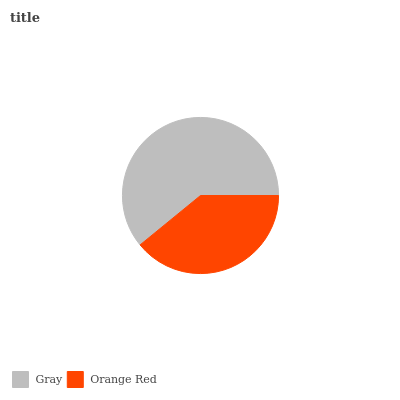Is Orange Red the minimum?
Answer yes or no. Yes. Is Gray the maximum?
Answer yes or no. Yes. Is Orange Red the maximum?
Answer yes or no. No. Is Gray greater than Orange Red?
Answer yes or no. Yes. Is Orange Red less than Gray?
Answer yes or no. Yes. Is Orange Red greater than Gray?
Answer yes or no. No. Is Gray less than Orange Red?
Answer yes or no. No. Is Gray the high median?
Answer yes or no. Yes. Is Orange Red the low median?
Answer yes or no. Yes. Is Orange Red the high median?
Answer yes or no. No. Is Gray the low median?
Answer yes or no. No. 